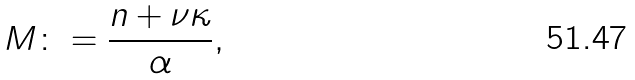Convert formula to latex. <formula><loc_0><loc_0><loc_500><loc_500>M \colon = \frac { n + \nu \kappa } { \alpha } ,</formula> 